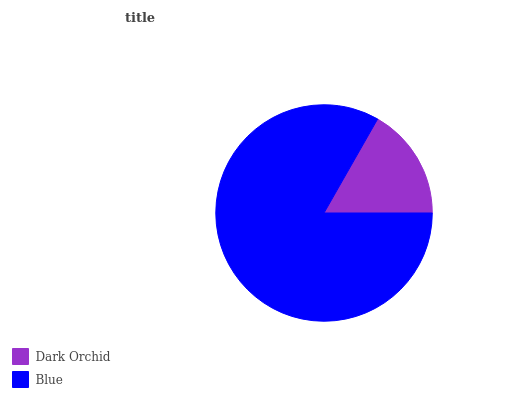Is Dark Orchid the minimum?
Answer yes or no. Yes. Is Blue the maximum?
Answer yes or no. Yes. Is Blue the minimum?
Answer yes or no. No. Is Blue greater than Dark Orchid?
Answer yes or no. Yes. Is Dark Orchid less than Blue?
Answer yes or no. Yes. Is Dark Orchid greater than Blue?
Answer yes or no. No. Is Blue less than Dark Orchid?
Answer yes or no. No. Is Blue the high median?
Answer yes or no. Yes. Is Dark Orchid the low median?
Answer yes or no. Yes. Is Dark Orchid the high median?
Answer yes or no. No. Is Blue the low median?
Answer yes or no. No. 